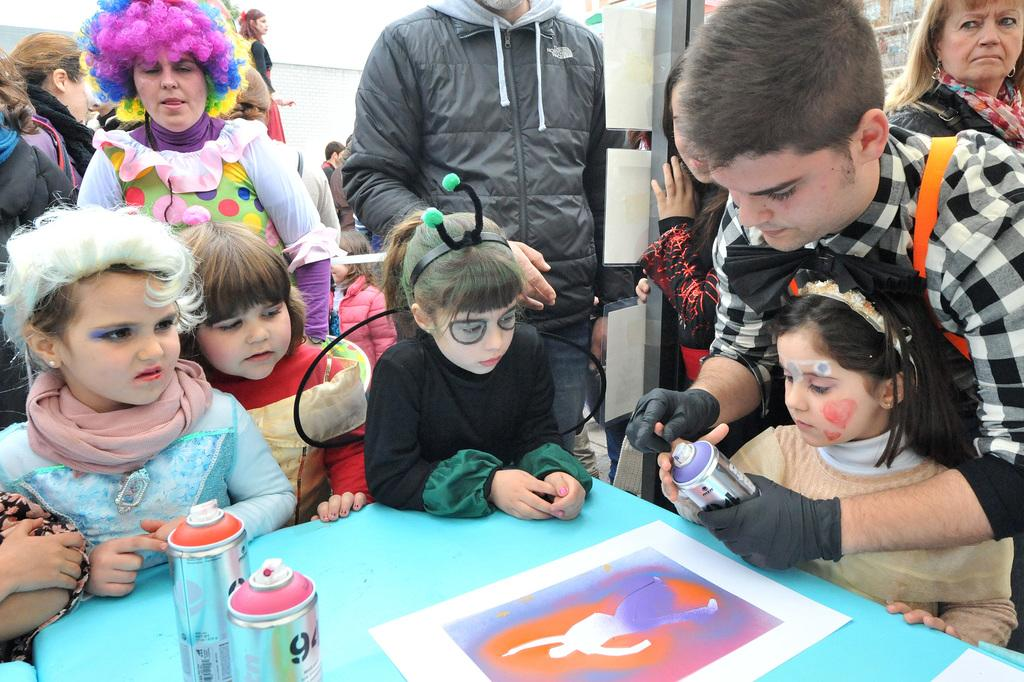How many people are in the image? There is a group of people in the image. What is the color of the wall in the background? There is a white color wall in the image. What is located in the front of the image? There is a table in the front of the image. What items can be seen on the table? There are bottles and a poster on the table. What type of locket is hanging from the eye of the person in the image? There is no person with an eye or a locket present in the image. 